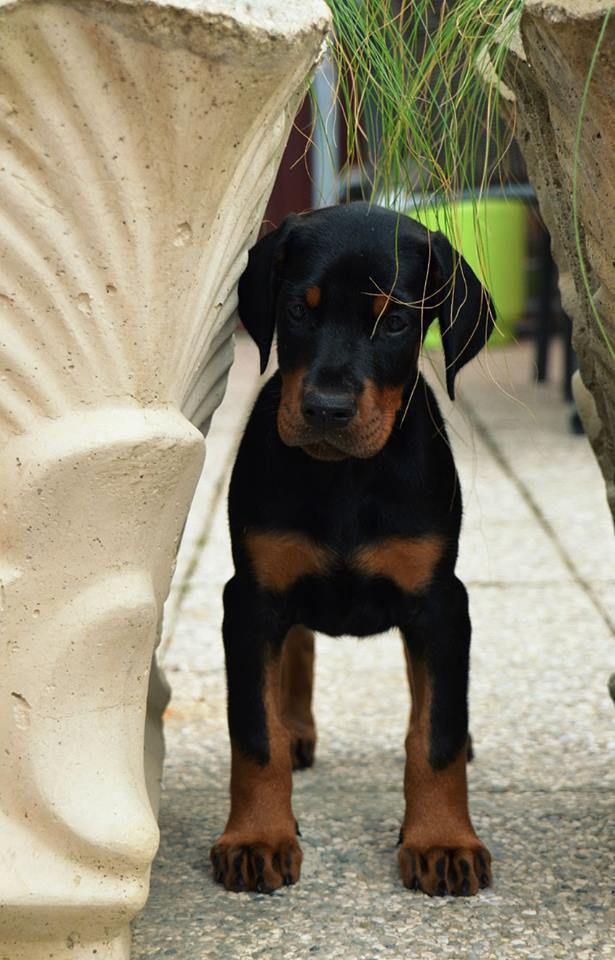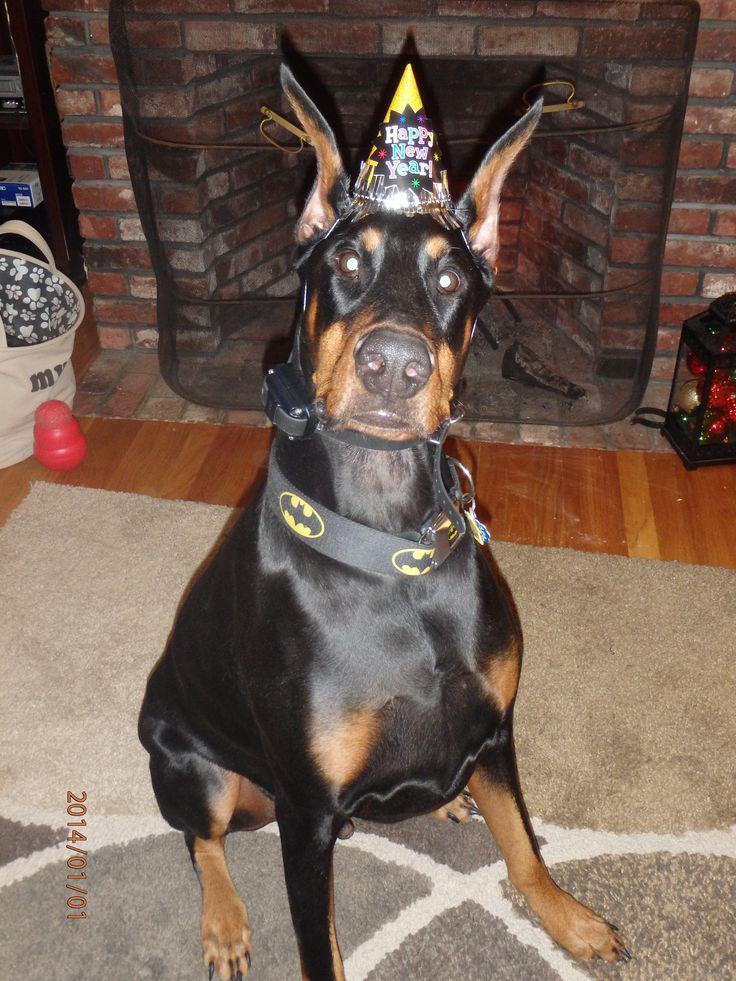The first image is the image on the left, the second image is the image on the right. Given the left and right images, does the statement "The left image contains one adult doberman with erect ears and its face straight ahead, and the right image includes at least one doberman reclining on something soft." hold true? Answer yes or no. No. The first image is the image on the left, the second image is the image on the right. Analyze the images presented: Is the assertion "The left and right image contains the same number of dogs, one being a puppy and the other being an adult." valid? Answer yes or no. Yes. 